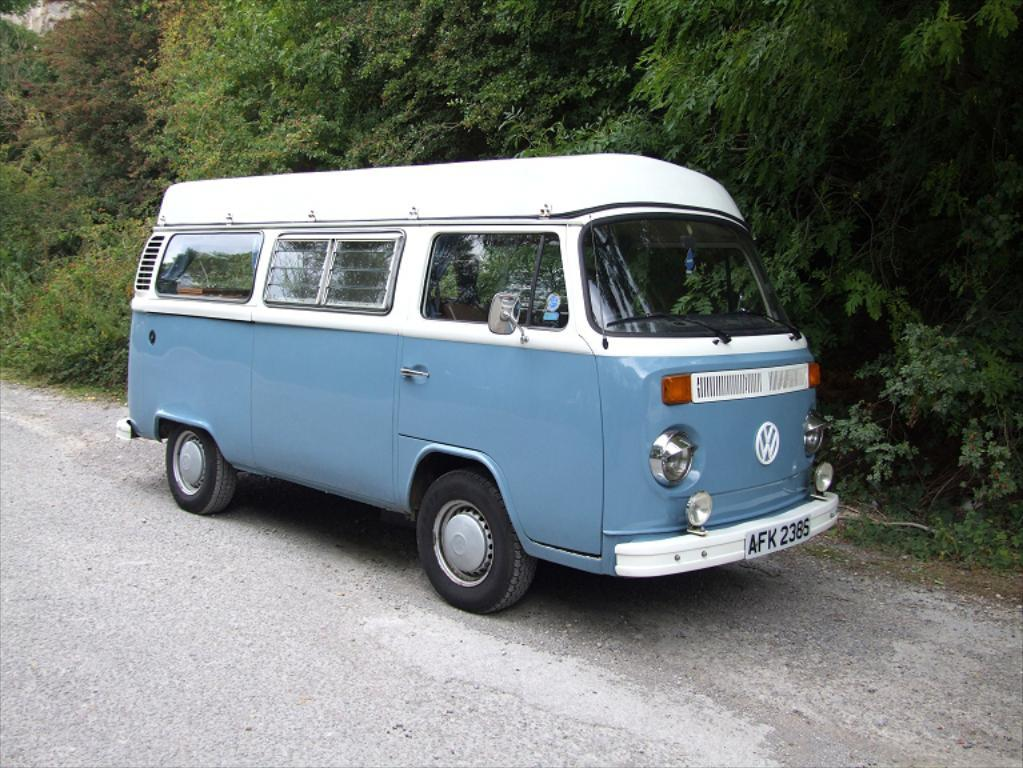What is the main subject of the image? There is a vehicle in the image. Where is the vehicle located? The vehicle is on the road. What colors can be seen on the vehicle? The vehicle is white and grey in color. What can be seen in the background of the image? There are trees in the background of the image. How many units of finger loss can be observed in the image? There is no reference to fingers or loss in the image, so it is not possible to determine any unit of finger loss. 